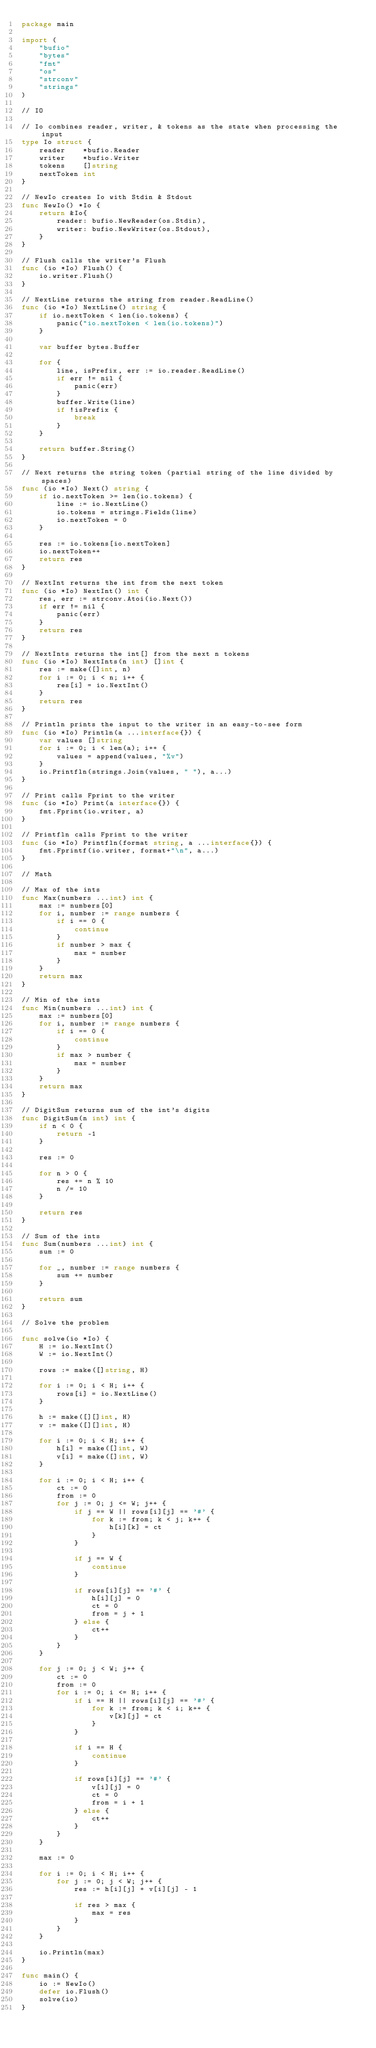Convert code to text. <code><loc_0><loc_0><loc_500><loc_500><_Go_>package main

import (
	"bufio"
	"bytes"
	"fmt"
	"os"
	"strconv"
	"strings"
)

// IO

// Io combines reader, writer, & tokens as the state when processing the input
type Io struct {
	reader    *bufio.Reader
	writer    *bufio.Writer
	tokens    []string
	nextToken int
}

// NewIo creates Io with Stdin & Stdout
func NewIo() *Io {
	return &Io{
		reader: bufio.NewReader(os.Stdin),
		writer: bufio.NewWriter(os.Stdout),
	}
}

// Flush calls the writer's Flush
func (io *Io) Flush() {
	io.writer.Flush()
}

// NextLine returns the string from reader.ReadLine()
func (io *Io) NextLine() string {
	if io.nextToken < len(io.tokens) {
		panic("io.nextToken < len(io.tokens)")
	}

	var buffer bytes.Buffer

	for {
		line, isPrefix, err := io.reader.ReadLine()
		if err != nil {
			panic(err)
		}
		buffer.Write(line)
		if !isPrefix {
			break
		}
	}

	return buffer.String()
}

// Next returns the string token (partial string of the line divided by spaces)
func (io *Io) Next() string {
	if io.nextToken >= len(io.tokens) {
		line := io.NextLine()
		io.tokens = strings.Fields(line)
		io.nextToken = 0
	}

	res := io.tokens[io.nextToken]
	io.nextToken++
	return res
}

// NextInt returns the int from the next token
func (io *Io) NextInt() int {
	res, err := strconv.Atoi(io.Next())
	if err != nil {
		panic(err)
	}
	return res
}

// NextInts returns the int[] from the next n tokens
func (io *Io) NextInts(n int) []int {
	res := make([]int, n)
	for i := 0; i < n; i++ {
		res[i] = io.NextInt()
	}
	return res
}

// Println prints the input to the writer in an easy-to-see form
func (io *Io) Println(a ...interface{}) {
	var values []string
	for i := 0; i < len(a); i++ {
		values = append(values, "%v")
	}
	io.Printfln(strings.Join(values, " "), a...)
}

// Print calls Fprint to the writer
func (io *Io) Print(a interface{}) {
	fmt.Fprint(io.writer, a)
}

// Printfln calls Fprint to the writer
func (io *Io) Printfln(format string, a ...interface{}) {
	fmt.Fprintf(io.writer, format+"\n", a...)
}

// Math

// Max of the ints
func Max(numbers ...int) int {
	max := numbers[0]
	for i, number := range numbers {
		if i == 0 {
			continue
		}
		if number > max {
			max = number
		}
	}
	return max
}

// Min of the ints
func Min(numbers ...int) int {
	max := numbers[0]
	for i, number := range numbers {
		if i == 0 {
			continue
		}
		if max > number {
			max = number
		}
	}
	return max
}

// DigitSum returns sum of the int's digits
func DigitSum(n int) int {
	if n < 0 {
		return -1
	}

	res := 0

	for n > 0 {
		res += n % 10
		n /= 10
	}

	return res
}

// Sum of the ints
func Sum(numbers ...int) int {
	sum := 0

	for _, number := range numbers {
		sum += number
	}

	return sum
}

// Solve the problem

func solve(io *Io) {
	H := io.NextInt()
	W := io.NextInt()

	rows := make([]string, H)

	for i := 0; i < H; i++ {
		rows[i] = io.NextLine()
	}

	h := make([][]int, H)
	v := make([][]int, H)

	for i := 0; i < H; i++ {
		h[i] = make([]int, W)
		v[i] = make([]int, W)
	}

	for i := 0; i < H; i++ {
		ct := 0
		from := 0
		for j := 0; j <= W; j++ {
			if j == W || rows[i][j] == '#' {
				for k := from; k < j; k++ {
					h[i][k] = ct
				}
			}

			if j == W {
				continue
			}

			if rows[i][j] == '#' {
				h[i][j] = 0
				ct = 0
				from = j + 1
			} else {
				ct++
			}
		}
	}

	for j := 0; j < W; j++ {
		ct := 0
		from := 0
		for i := 0; i <= H; i++ {
			if i == H || rows[i][j] == '#' {
				for k := from; k < i; k++ {
					v[k][j] = ct
				}
			}

			if i == H {
				continue
			}

			if rows[i][j] == '#' {
				v[i][j] = 0
				ct = 0
				from = i + 1
			} else {
				ct++
			}
		}
	}

	max := 0

	for i := 0; i < H; i++ {
		for j := 0; j < W; j++ {
			res := h[i][j] + v[i][j] - 1

			if res > max {
				max = res
			}
		}
	}

	io.Println(max)
}

func main() {
	io := NewIo()
	defer io.Flush()
	solve(io)
}
</code> 